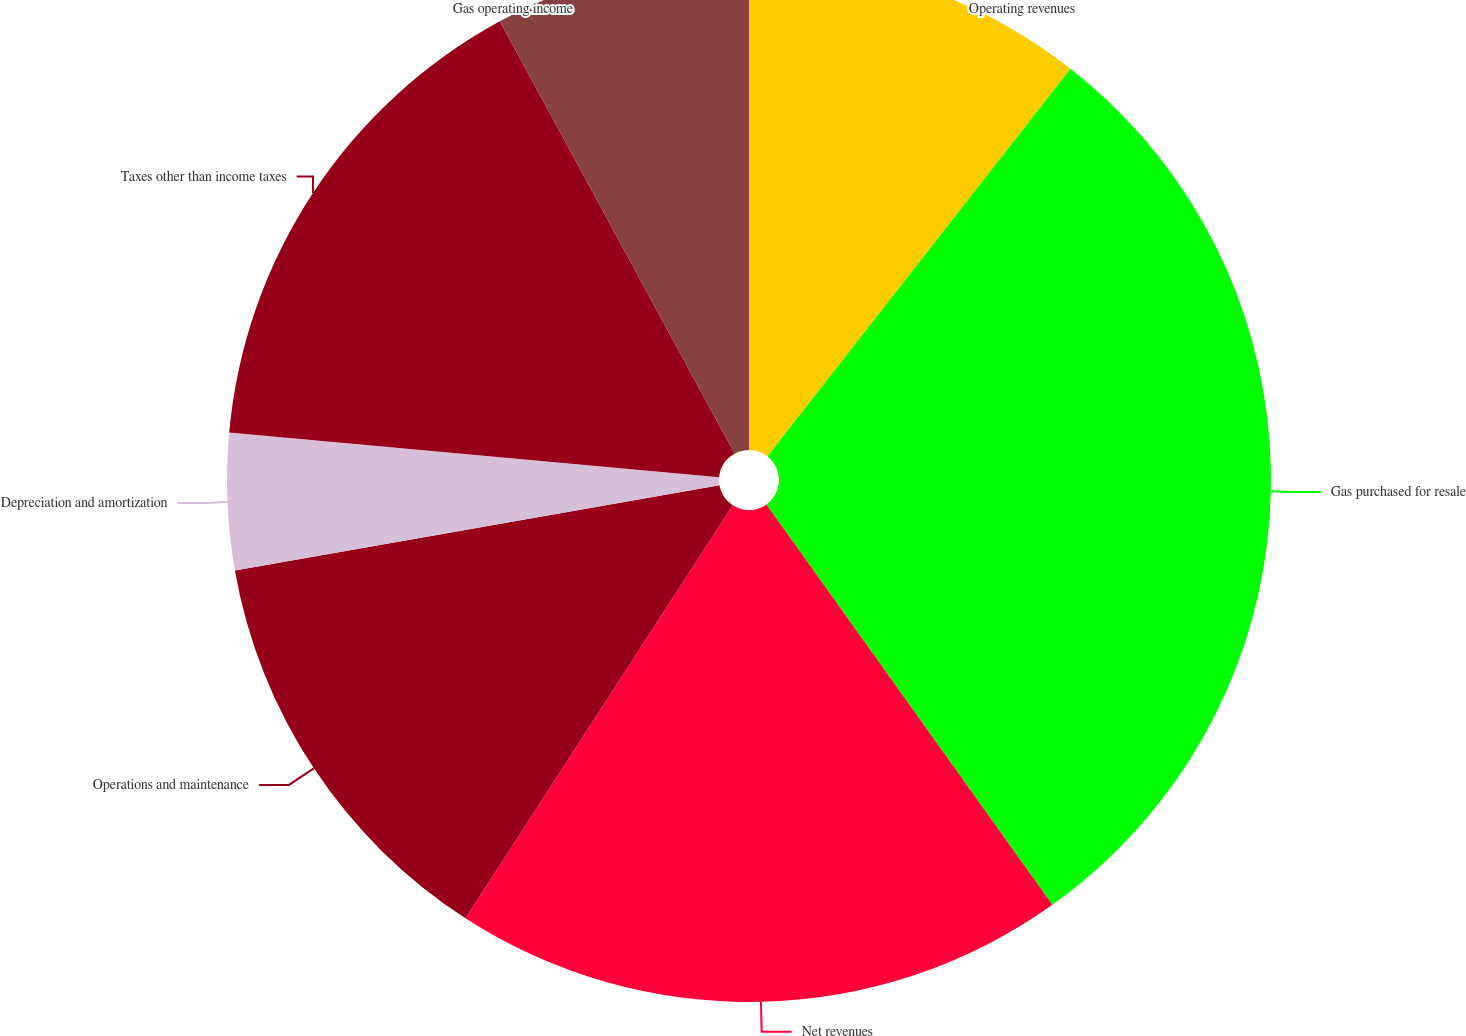Convert chart. <chart><loc_0><loc_0><loc_500><loc_500><pie_chart><fcel>Operating revenues<fcel>Gas purchased for resale<fcel>Net revenues<fcel>Operations and maintenance<fcel>Depreciation and amortization<fcel>Taxes other than income taxes<fcel>Gas operating income<nl><fcel>10.56%<fcel>29.57%<fcel>19.01%<fcel>13.09%<fcel>4.22%<fcel>15.63%<fcel>7.92%<nl></chart> 